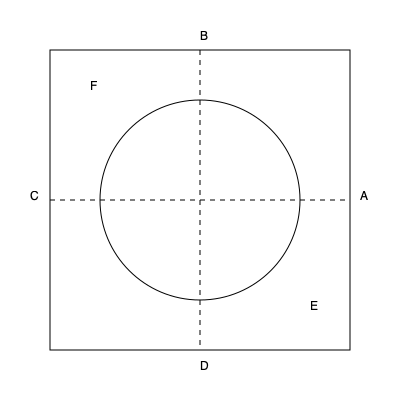In the given patent infringement diagram, which area(s) could potentially represent a non-infringing use of the patented technology if the patent claims cover the entire square but exclude the circular region? To answer this question, we need to analyze the diagram and understand the implications of the patent claims:

1. The large square (ABCD) represents the entire scope of the patented technology.
2. The circle in the center is explicitly excluded from the patent claims.
3. We need to identify areas that fall outside the patented region but within the square.

Step-by-step analysis:
1. The square ABCD represents the full scope of the patent.
2. The circle is excluded from the patent claims.
3. The areas to focus on are the corners of the square that fall outside the circle.
4. These areas are represented by the regions in the corners, such as near points E and F.
5. The regions near E and F are within the square (patented area) but outside the circle (excluded area).
6. Therefore, these corner regions potentially represent non-infringing uses of the technology.

It's important to note that the exact boundaries of these regions would depend on the specific language of the patent claims and the interpretation of the diagram in the context of the technology.
Answer: The corner regions of the square outside the circle (e.g., near points E and F) 